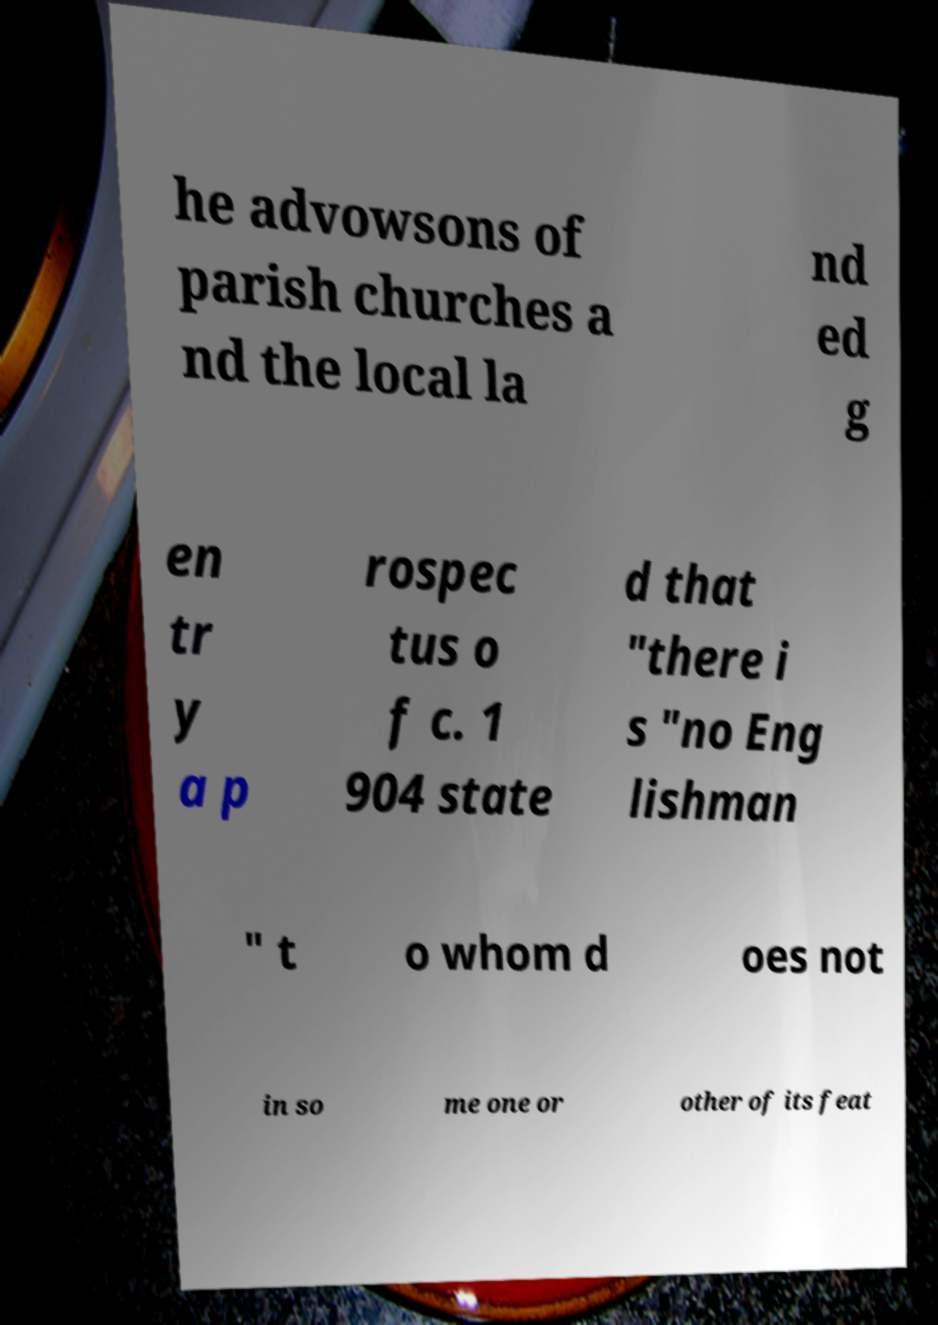Can you accurately transcribe the text from the provided image for me? he advowsons of parish churches a nd the local la nd ed g en tr y a p rospec tus o f c. 1 904 state d that "there i s "no Eng lishman " t o whom d oes not in so me one or other of its feat 